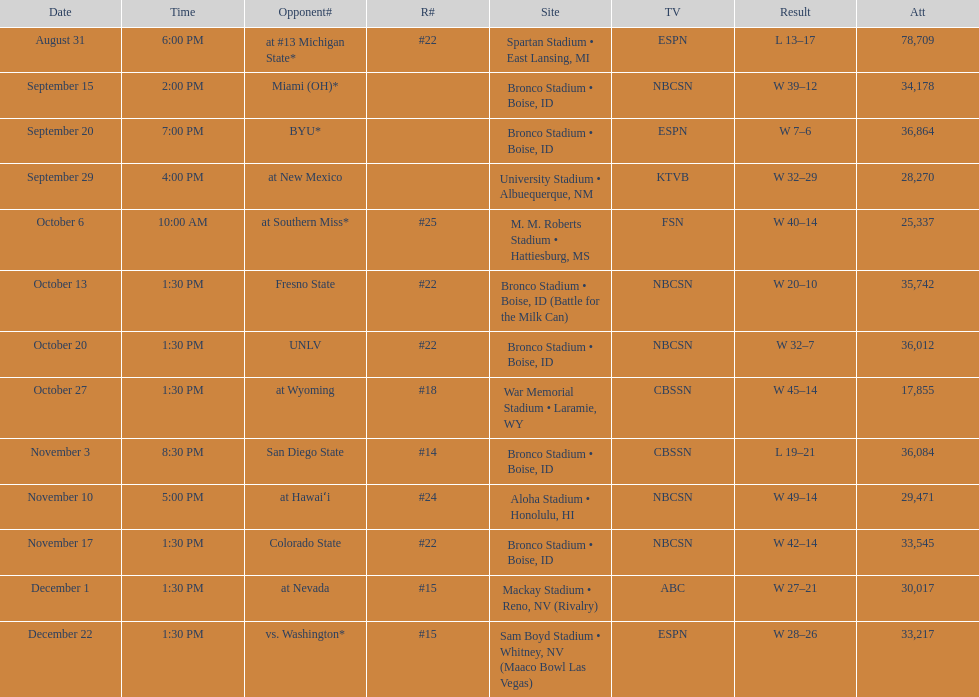What is the score difference for the game against michigan state? 4. 